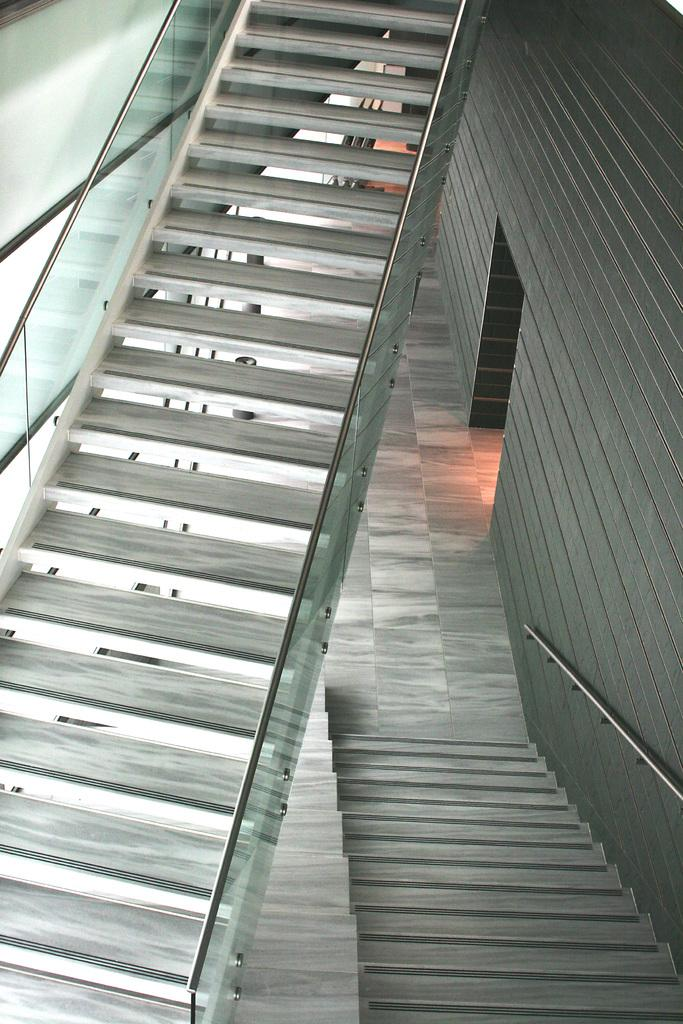What type of architectural feature can be seen in the image? There are staircases in the image. What color is the building on the right side of the image? The building on the right side of the image is in brown color. What type of windows are present on the left side of the image? There are glass windows on the left side of the image. What is the price of the steam coming out of the building in the image? There is no steam coming out of the building in the image, and therefore no price can be determined. 